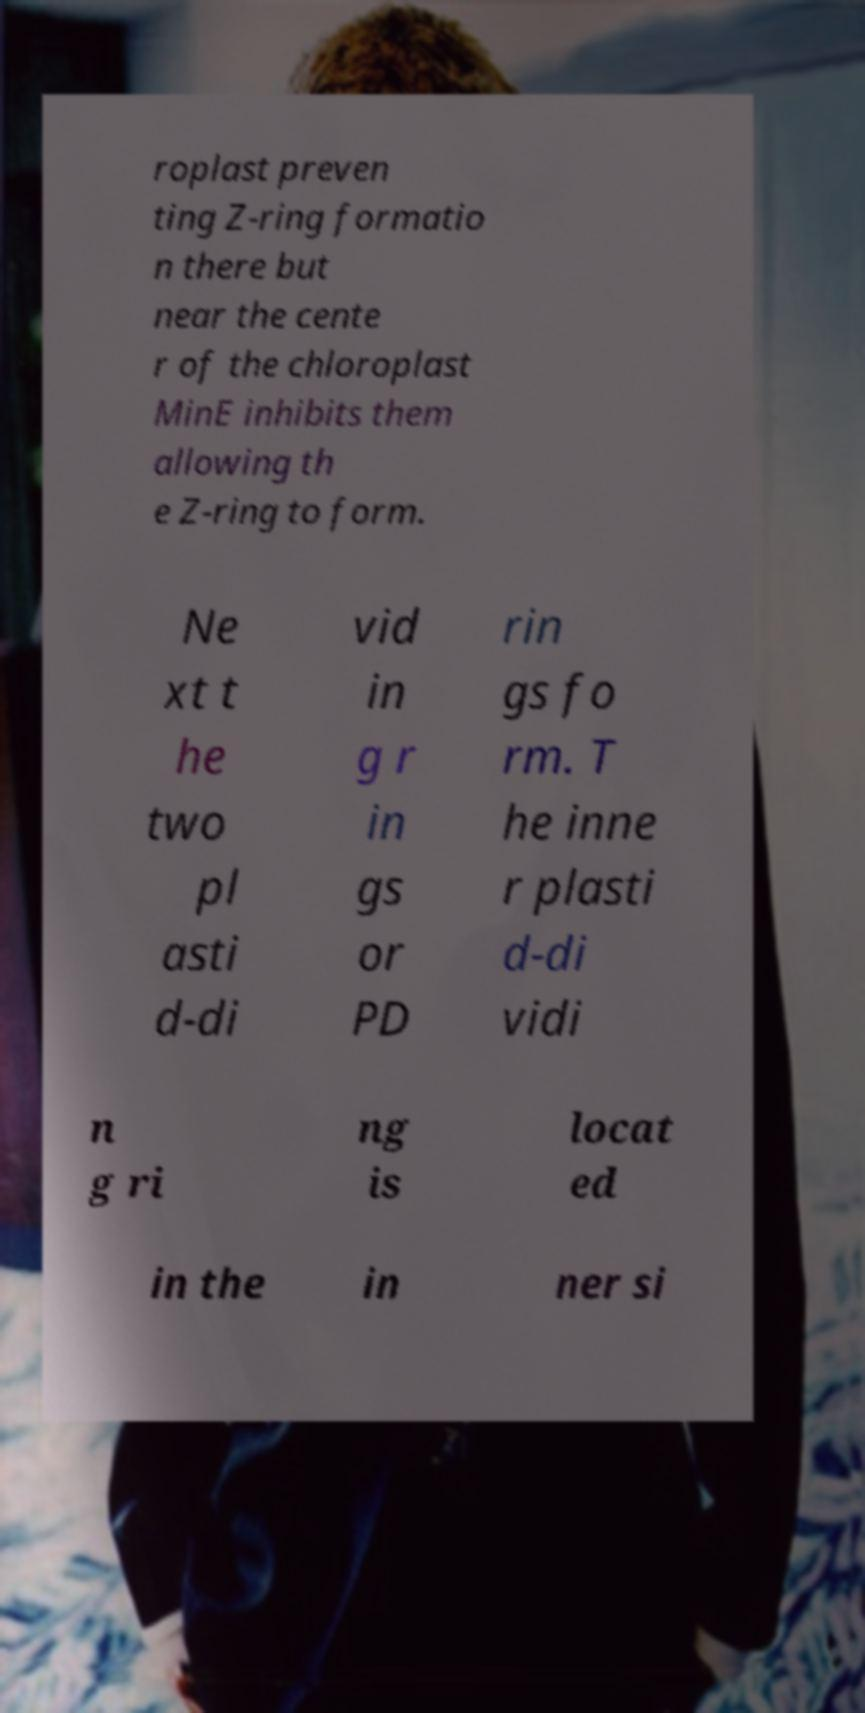Could you extract and type out the text from this image? roplast preven ting Z-ring formatio n there but near the cente r of the chloroplast MinE inhibits them allowing th e Z-ring to form. Ne xt t he two pl asti d-di vid in g r in gs or PD rin gs fo rm. T he inne r plasti d-di vidi n g ri ng is locat ed in the in ner si 